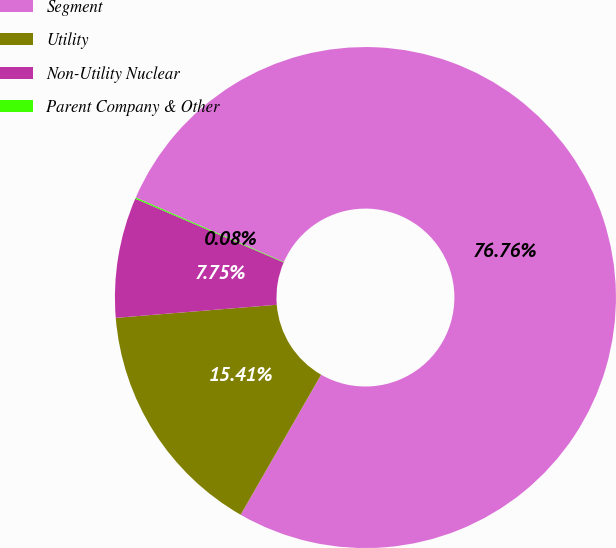<chart> <loc_0><loc_0><loc_500><loc_500><pie_chart><fcel>Segment<fcel>Utility<fcel>Non-Utility Nuclear<fcel>Parent Company & Other<nl><fcel>76.76%<fcel>15.41%<fcel>7.75%<fcel>0.08%<nl></chart> 